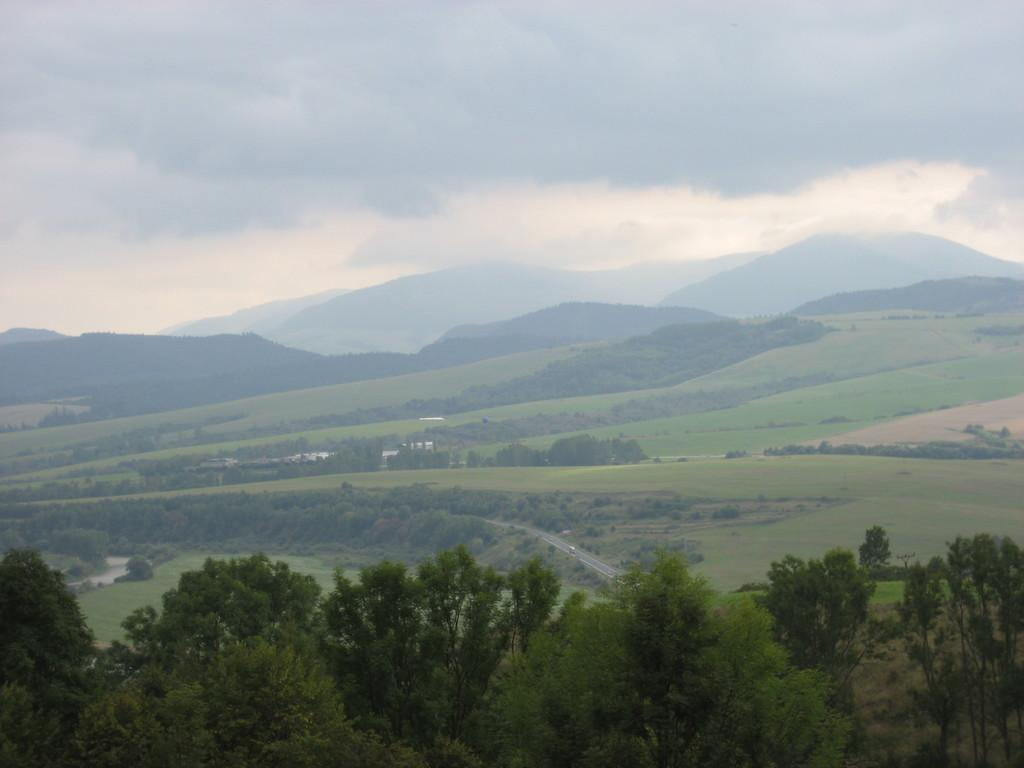What type of vegetation is present in the image? There is grass, plants, and many trees in the image. What can be seen in the background of the image? There are mountains, clouds, and the sky visible in the background of the image. Can you describe the sky in the image? The sky is visible in the background of the image. What type of button can be seen on the trees in the image? There are no buttons present on the trees in the image. How does the acoustics of the image affect the sound of the wind? The image does not provide information about the acoustics, so it is impossible to determine how the sound of the wind might be affected. 